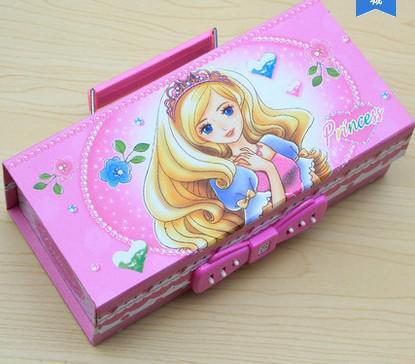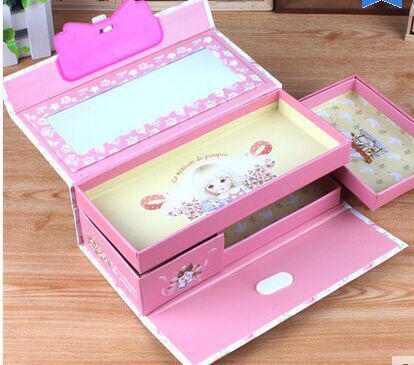The first image is the image on the left, the second image is the image on the right. For the images shown, is this caption "At least one of the pencil cases opens and closes with a zipper." true? Answer yes or no. No. The first image is the image on the left, the second image is the image on the right. Given the left and right images, does the statement "One image shows a closed hard-sided pencil case with a big-eyed cartoon girl on the front, and the other shows an open pink-and-white case." hold true? Answer yes or no. Yes. 